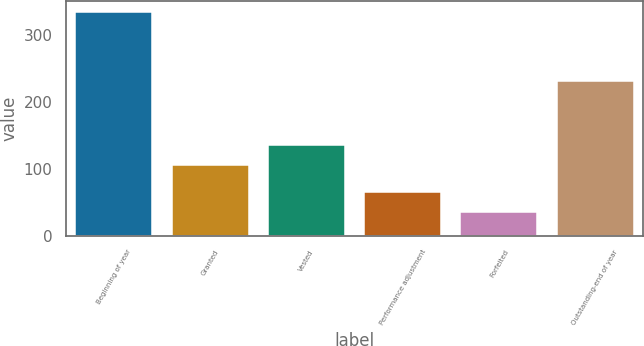<chart> <loc_0><loc_0><loc_500><loc_500><bar_chart><fcel>Beginning of year<fcel>Granted<fcel>Vested<fcel>Performance adjustment<fcel>Forfeited<fcel>Outstanding-end of year<nl><fcel>334<fcel>105<fcel>134.9<fcel>64.9<fcel>35<fcel>231<nl></chart> 